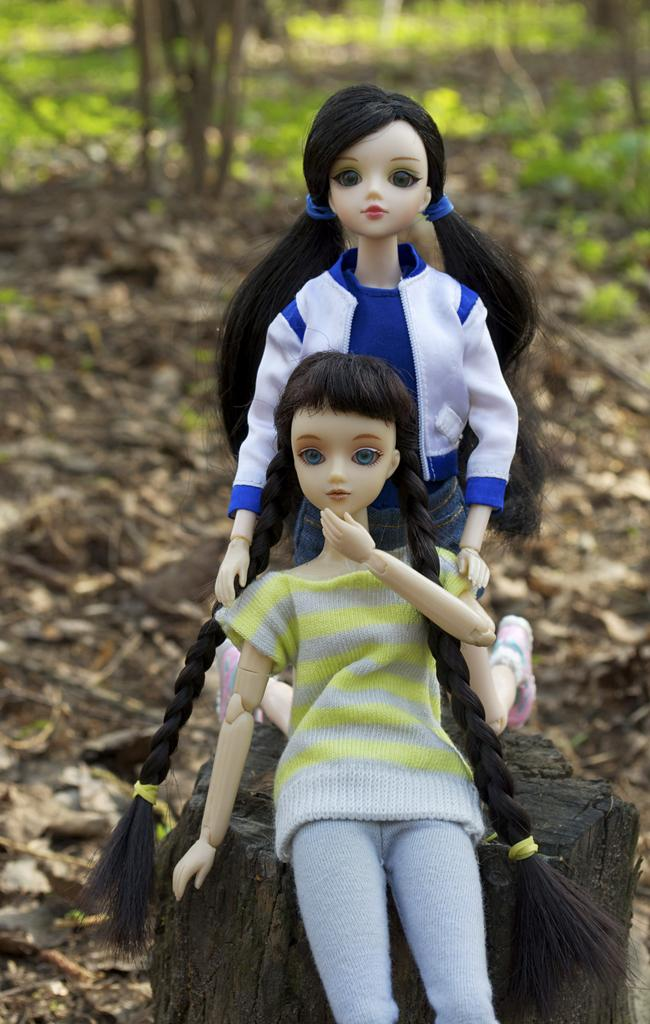What objects are on the trunk in the image? There are two dolls on a trunk in the image. What type of natural elements can be seen in the image? Trees and plants are visible in the image. What is present on the floor in the image? Dry leaves are present on the floor. How many friends are visible in the image? There is no mention of friends in the image; it features two dolls on a trunk. What type of yard is visible in the image? There is no yard visible in the image; it features trees and plants, but no yard is mentioned. 